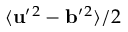Convert formula to latex. <formula><loc_0><loc_0><loc_500><loc_500>\langle { { u } ^ { \prime ^ { 2 } - { b } ^ { \prime ^ { 2 } } \rangle / 2</formula> 